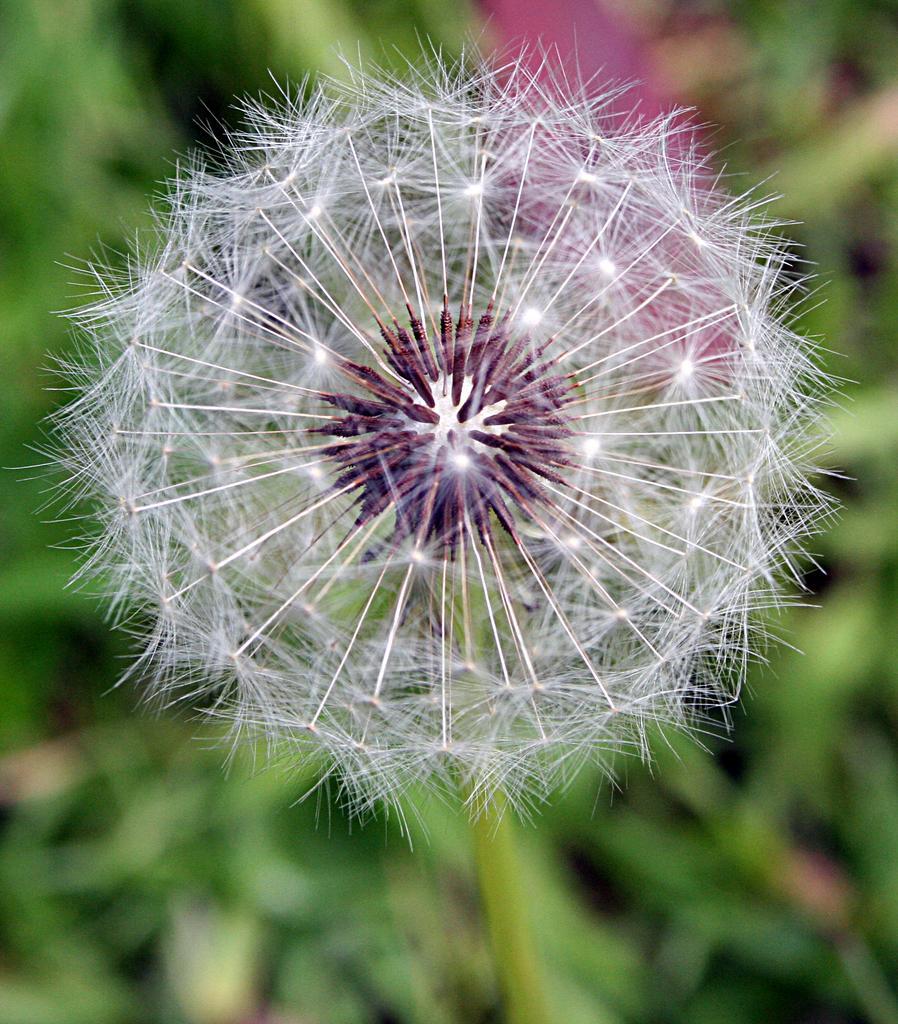Can you describe this image briefly? In this image we can see a flower. 